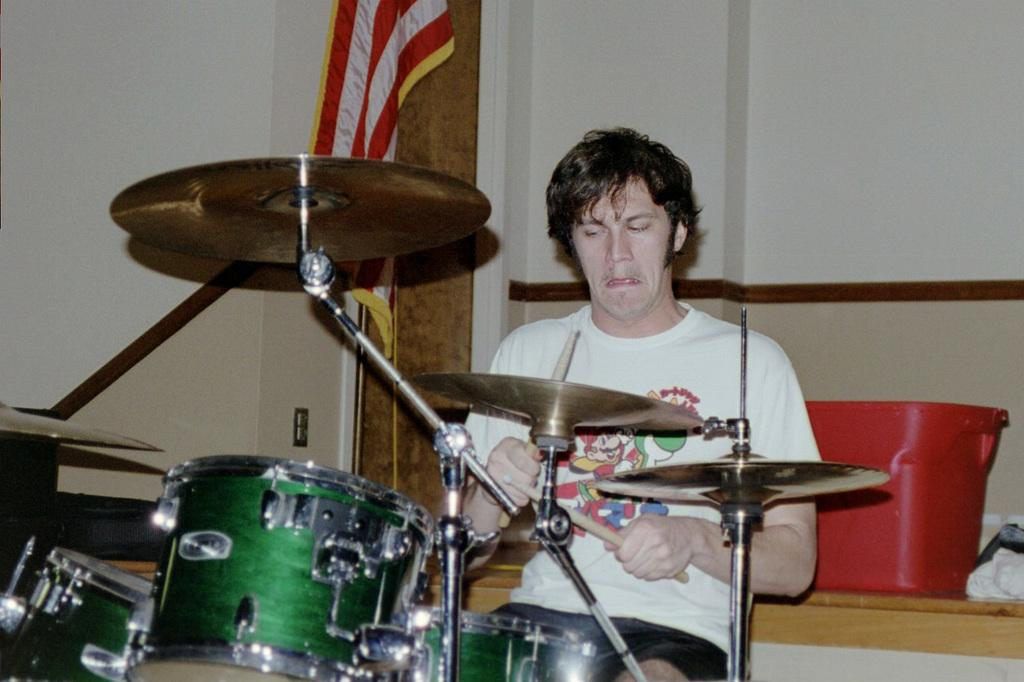What is the person in the image doing? The person in the image is playing musical instruments. What can be seen in the background of the image? There is a wall, a basket, a flag, and cloth in the background of the image. What type of leather is used to make the end of the screw visible in the image? There is no leather, end, or screw present in the image. 